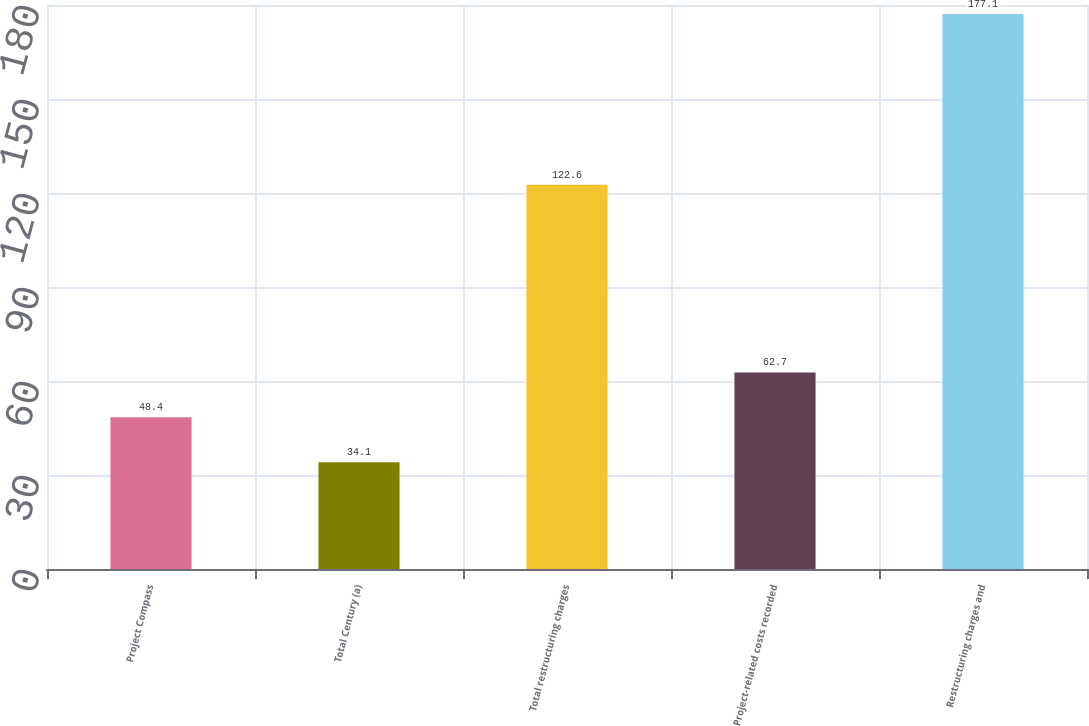Convert chart to OTSL. <chart><loc_0><loc_0><loc_500><loc_500><bar_chart><fcel>Project Compass<fcel>Total Century (a)<fcel>Total restructuring charges<fcel>Project-related costs recorded<fcel>Restructuring charges and<nl><fcel>48.4<fcel>34.1<fcel>122.6<fcel>62.7<fcel>177.1<nl></chart> 